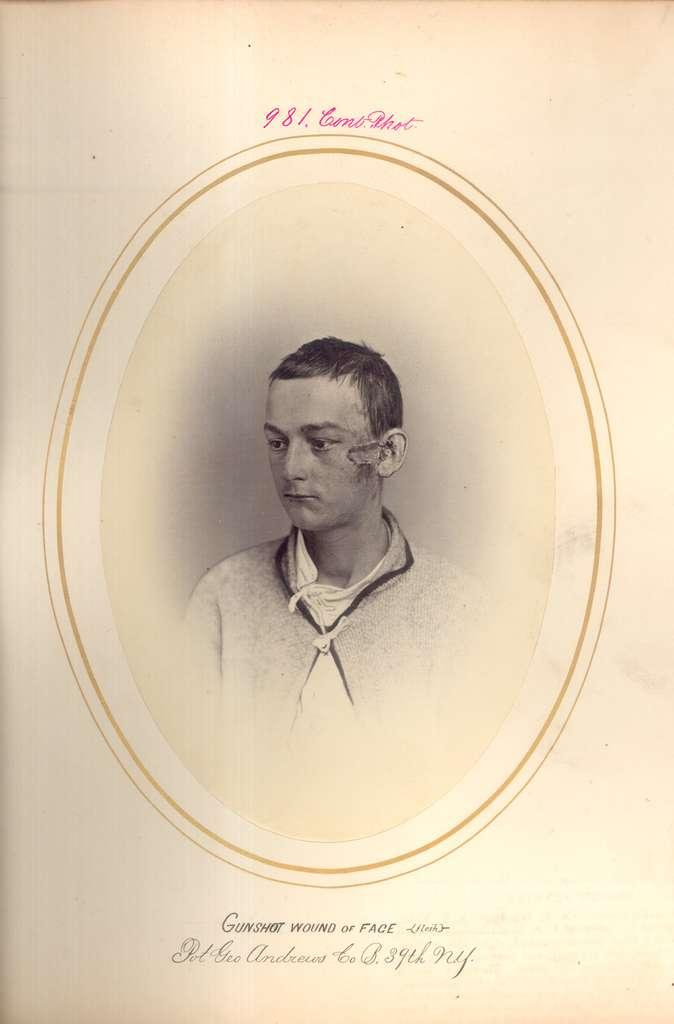What is the main subject of the image? There is an image of a person in the image. What else can be seen in the image besides the person? There is text at the top and bottom of the image. Can you see a toad wearing a crown in the image? There is no toad or crown present in the image. 